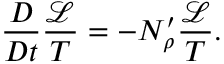Convert formula to latex. <formula><loc_0><loc_0><loc_500><loc_500>\frac { D } { D t } \frac { \mathcal { L } } { T } = - N _ { \rho } ^ { \prime } \frac { \mathcal { L } } { T } .</formula> 